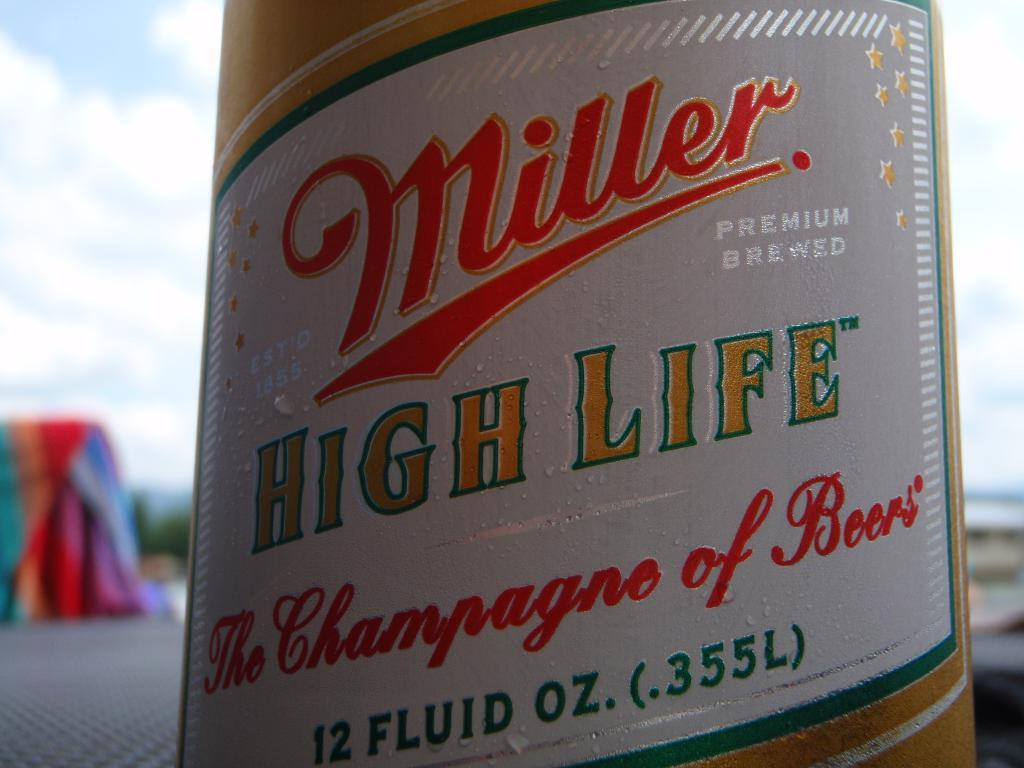What is the main object in the center of the image? There is a bottle in the center of the image. What is written on the bottle? The bottle has the words "high life" written on it. What type of coach can be seen in the background of the image? There is no coach visible in the image; it only features a bottle with the words "high life" written on it. 